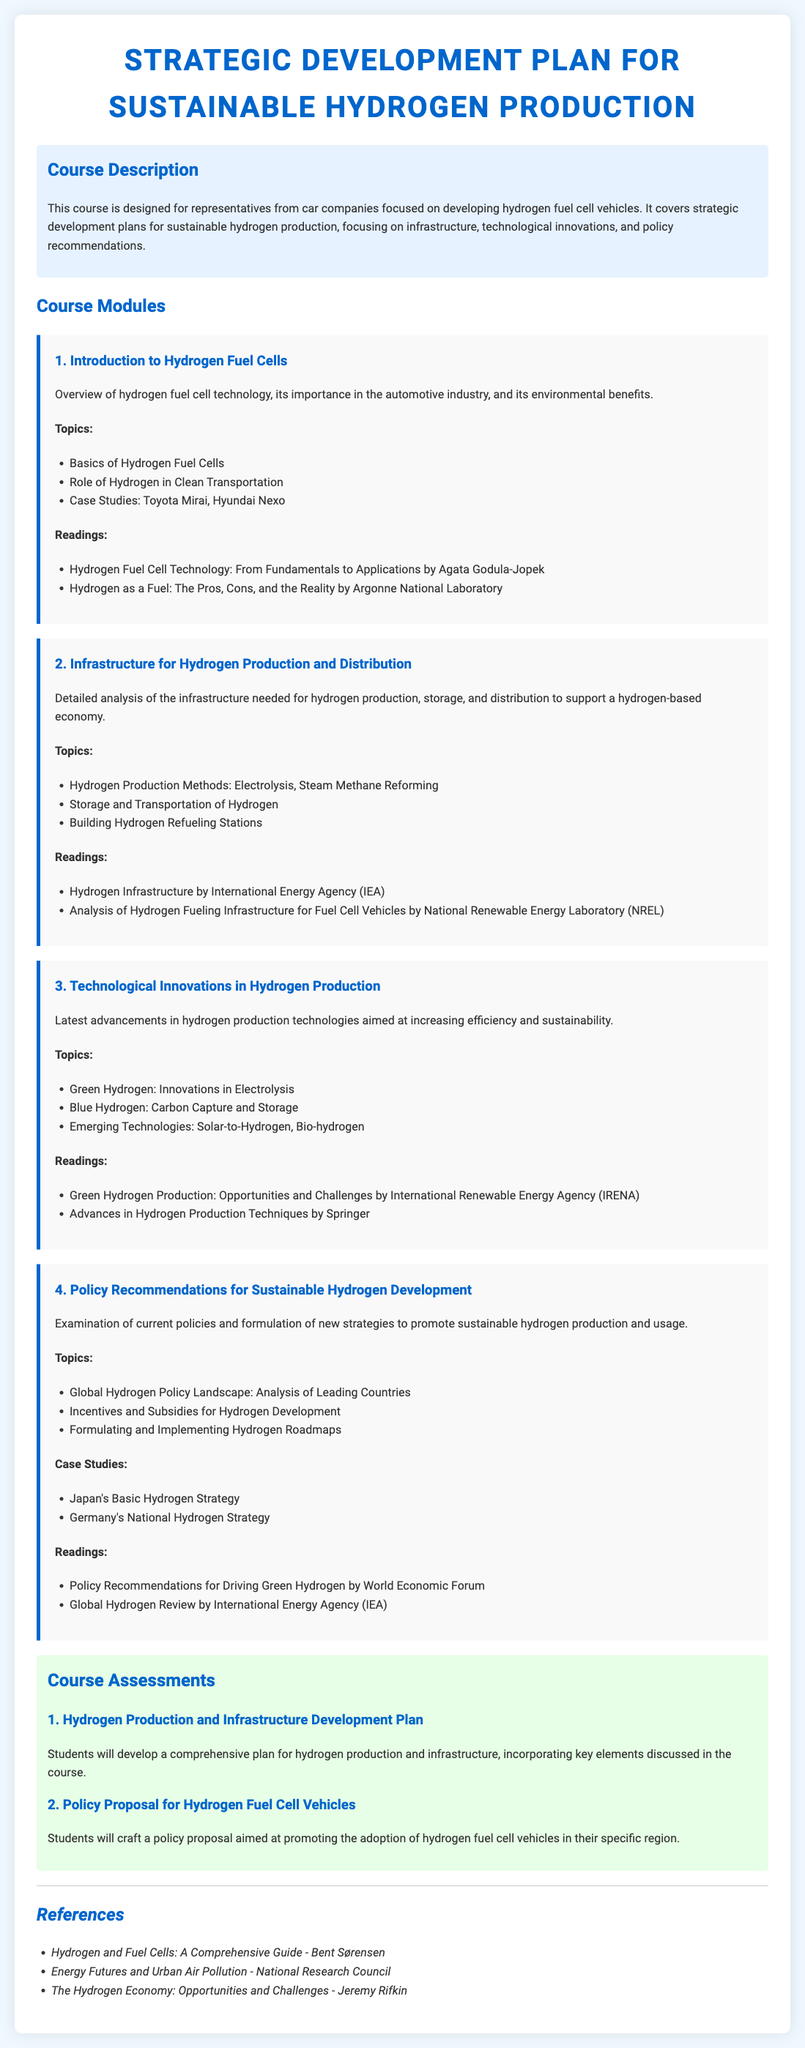What is the title of the syllabus? The title of the syllabus is prominently displayed at the top of the document, indicating the focus of the course.
Answer: Strategic Development Plan for Sustainable Hydrogen Production Who is the target audience for this course? The course description specifies that it is designed for a particular audience, highlighting the intended participants.
Answer: Representatives from car companies focused on developing hydrogen fuel cell vehicles What is the first module in the syllabus? The first module is outlined in the course modules section, identifying the initial focus of the course.
Answer: Introduction to Hydrogen Fuel Cells How many case studies are included in the fourth module? The fourth module lists the specific case studies included, providing a quantitative aspect to the content.
Answer: 2 Which reading is associated with the second module? Specific readings are assigned to each module, and one is tied to the second module according to the document.
Answer: Analysis of Hydrogen Fueling Infrastructure for Fuel Cell Vehicles by National Renewable Energy Laboratory (NREL) What is the first type of course assessment? The course assessments section outlines two types of evaluations, with the first one specified clearly.
Answer: Hydrogen Production and Infrastructure Development Plan What is the background color of the course description section? The color scheme is described in the CSS styles, indicating the visual aspects of the different sections of the document.
Answer: Light blue How many main topics are there in the third module? The content of each module includes a list of topics, and this question asks for the quantity in a specific module.
Answer: 3 